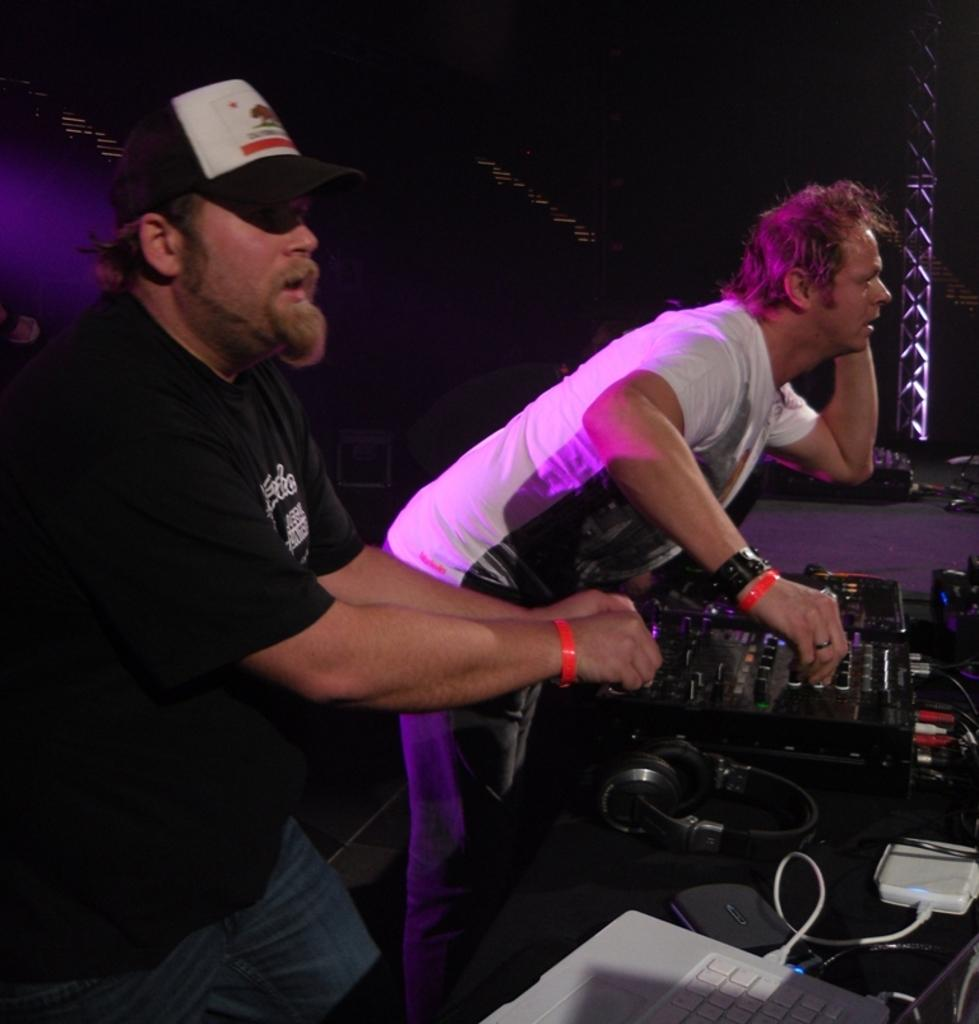How many people are in the image? There are two men standing in the image. What are the men wearing on their heads? The men are wearing headsets. What electronic device can be seen in the image? There is a laptop in the image. What else is visible in the image besides the laptop? There are wires visible in the image. What is the color of the background in the image? The background of the image is dark. What is the aftermath of the show in the image? There is no show or aftermath mentioned in the image; it only features two men wearing headsets, a laptop, and wires. How old is the boy in the image? There is no boy present in the image. 